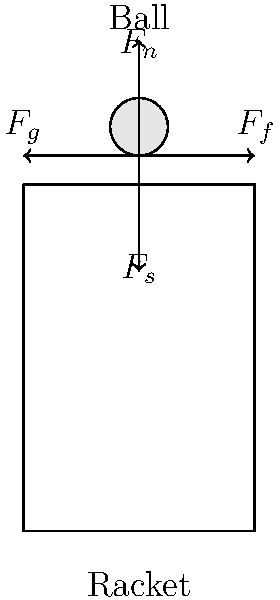During impact with a tennis ball, which force acting on the racket is primarily responsible for the ball's change in direction? To answer this question, let's analyze the forces acting on the tennis racket during impact:

1. $F_n$: Normal force - This is the force exerted by the ball perpendicular to the racket's surface.
2. $F_s$: String tension force - This force is due to the tension in the racket strings.
3. $F_f$: Friction force - This force acts parallel to the racket's surface and opposes the ball's motion along the strings.
4. $F_g$: Grip force - This is the force exerted by the player's hand on the racket handle.

The primary force responsible for changing the ball's direction is the normal force ($F_n$). This force acts perpendicular to the racket's surface and is the main component that redirects the ball's momentum.

Here's why:

1. The normal force is the direct result of the collision between the ball and the racket surface.
2. According to Newton's Third Law, the racket exerts an equal and opposite force on the ball.
3. This force is what primarily alters the ball's velocity vector, changing its direction.

While the other forces play important roles in the overall dynamics of the impact (e.g., $F_s$ affects the ball's speed, $F_f$ influences spin, and $F_g$ controls the racket's stability), it is the normal force that is principally responsible for redirecting the ball.
Answer: Normal force ($F_n$) 